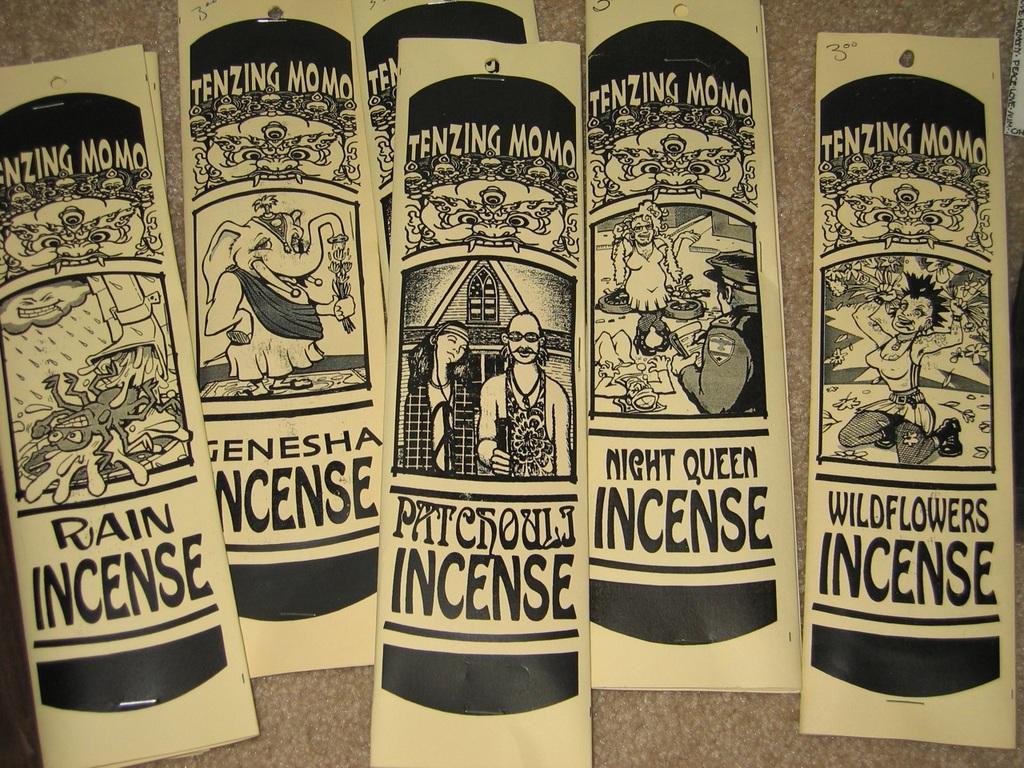Describe this image in one or two sentences. In this image there are comics on a brown surface. We can see images and something is written in the comics.  